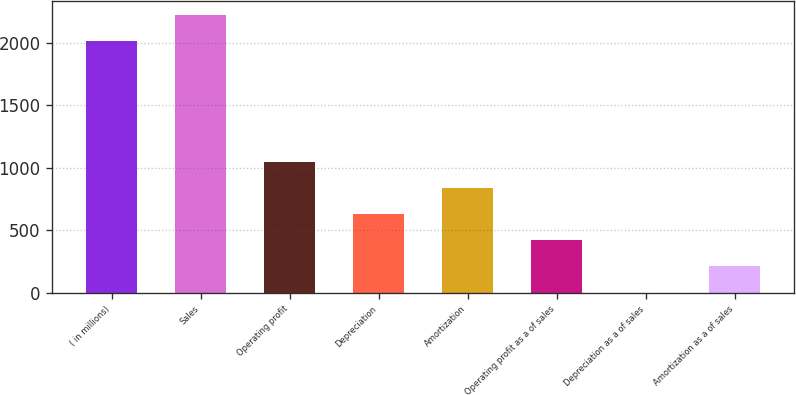<chart> <loc_0><loc_0><loc_500><loc_500><bar_chart><fcel>( in millions)<fcel>Sales<fcel>Operating profit<fcel>Depreciation<fcel>Amortization<fcel>Operating profit as a of sales<fcel>Depreciation as a of sales<fcel>Amortization as a of sales<nl><fcel>2013<fcel>2222.32<fcel>1048.3<fcel>629.66<fcel>838.98<fcel>420.34<fcel>1.7<fcel>211.02<nl></chart> 